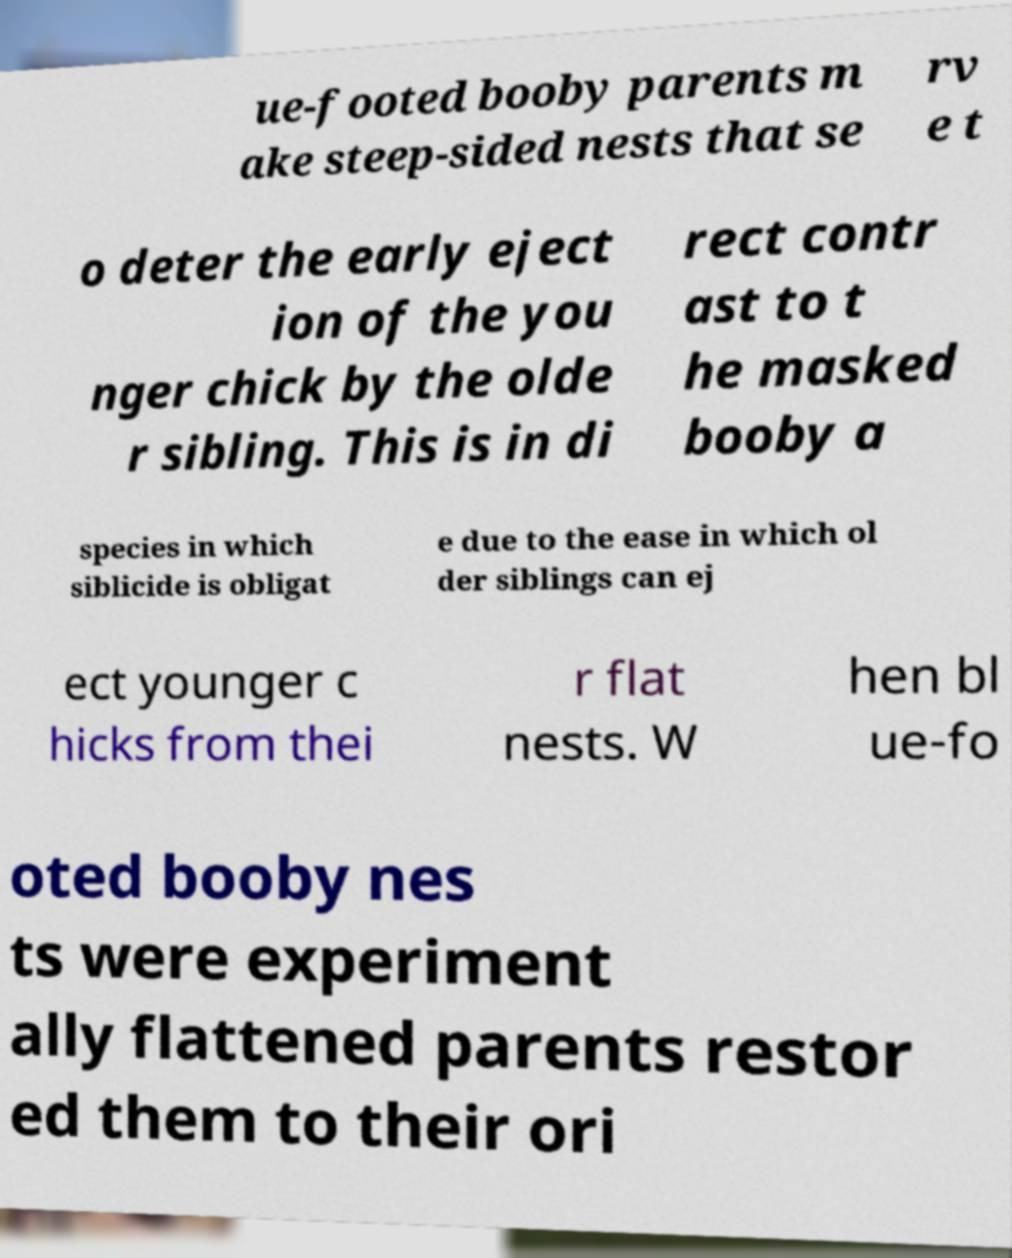Please read and relay the text visible in this image. What does it say? ue-footed booby parents m ake steep-sided nests that se rv e t o deter the early eject ion of the you nger chick by the olde r sibling. This is in di rect contr ast to t he masked booby a species in which siblicide is obligat e due to the ease in which ol der siblings can ej ect younger c hicks from thei r flat nests. W hen bl ue-fo oted booby nes ts were experiment ally flattened parents restor ed them to their ori 